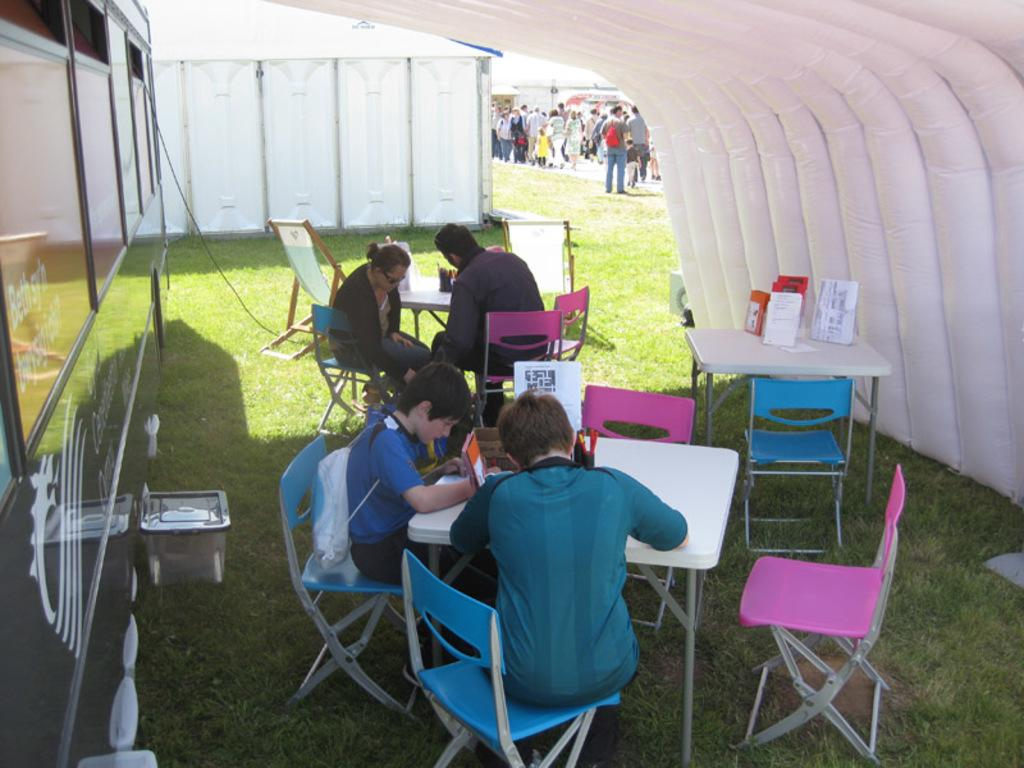What are the people in the image doing? The people in the image are sitting on chairs. Where are the chairs located? The chairs are around tables. What can be found on the tables? There are things on the tables. Are there any other people visible in the image? Yes, there are other people standing behind the seated people. What type of rice is being served on the tables in the image? There is no rice visible in the image; the tables have unspecified things on them. 